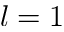<formula> <loc_0><loc_0><loc_500><loc_500>l = 1</formula> 